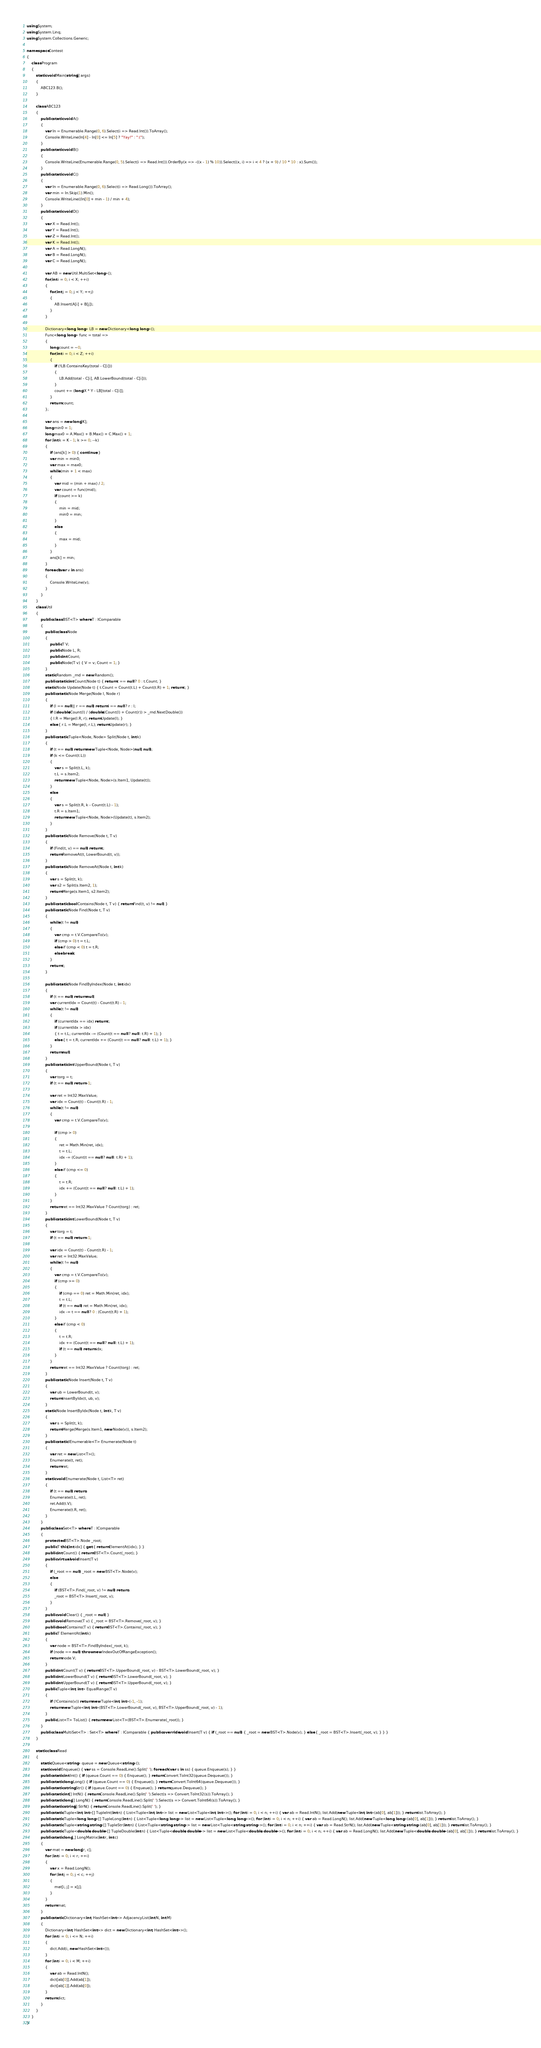<code> <loc_0><loc_0><loc_500><loc_500><_C#_>using System;
using System.Linq;
using System.Collections.Generic;

namespace Contest
{
    class Program
    {
        static void Main(string[] args)
        {
            ABC123.B();
        }

        class ABC123
        {
            public static void A()
            {
                var In = Enumerable.Range(0, 6).Select(i => Read.Int()).ToArray();
                Console.WriteLine(In[4] - In[0] <= In[5] ? "Yay!" : ":(");
            }
            public static void B()
            {
                Console.WriteLine(Enumerable.Range(0, 5).Select(i => Read.Int()).OrderBy(x => -((x - 1) % 10)).Select((x, i) => i < 4 ? (x + 9) / 10 * 10 : x).Sum());
            }
            public static void C()
            {
                var In = Enumerable.Range(0, 6).Select(i => Read.Long()).ToArray();
                var min = In.Skip(1).Min();
                Console.WriteLine((In[0] + min - 1) / min + 4);
            }
            public static void D()
            {
                var X = Read.Int();
                var Y = Read.Int();
                var Z = Read.Int();
                var K = Read.Int();
                var A = Read.LongN();
                var B = Read.LongN();
                var C = Read.LongN();

                var AB = new Util.MultiSet<long>();
                for(int i = 0; i < X; ++i)
                {
                    for(int j = 0; j < Y; ++j)
                    {
                        AB.Insert(A[i] + B[j]);
                    }
                }

                Dictionary<long, long> LB = new Dictionary<long, long>();
                Func<long, long> func = total =>
                {
                    long count = ~0;
                    for(int i = 0; i < Z; ++i)
                    {
                        if (!LB.ContainsKey(total - C[i]))
                        {
                            LB.Add(total - C[i], AB.LowerBound(total - C[i]));
                        }
                        count += (long)X * Y - LB[total - C[i]];
                    }
                    return count;
                };

                var ans = new long[K];
                long min0 = 1;
                long max0 = A.Max() + B.Max() + C.Max() + 1;
                for (int k = K - 1; k >= 0; --k)
                {
                    if (ans[k] > 0) { continue; }
                    var min = min0;
                    var max = max0;
                    while (min + 1 < max)
                    {
                        var mid = (min + max) / 2;
                        var count = func(mid);
                        if (count >= k)
                        {
                            min = mid;
                            min0 = min;
                        }
                        else
                        {
                            max = mid;
                        }
                    }
                    ans[k] = min;
                }
                foreach(var v in ans)
                {
                    Console.WriteLine(v);
                }
            }
        }
        class Util
        {
            public class BST<T> where T : IComparable
            {
                public class Node
                {
                    public T V;
                    public Node L, R;
                    public int Count;
                    public Node(T v) { V = v; Count = 1; }
                }
                static Random _rnd = new Random();
                public static int Count(Node t) { return t == null ? 0 : t.Count; }
                static Node Update(Node t) { t.Count = Count(t.L) + Count(t.R) + 1; return t; }
                public static Node Merge(Node l, Node r)
                {
                    if (l == null || r == null) return l == null ? r : l;
                    if ((double)Count(l) / (double)(Count(l) + Count(r)) > _rnd.NextDouble())
                    { l.R = Merge(l.R, r); return Update(l); }
                    else { r.L = Merge(l, r.L); return Update(r); }
                }
                public static Tuple<Node, Node> Split(Node t, int k)
                {
                    if (t == null) return new Tuple<Node, Node>(null, null);
                    if (k <= Count(t.L))
                    {
                        var s = Split(t.L, k);
                        t.L = s.Item2;
                        return new Tuple<Node, Node>(s.Item1, Update(t));
                    }
                    else
                    {
                        var s = Split(t.R, k - Count(t.L) - 1);
                        t.R = s.Item1;
                        return new Tuple<Node, Node>(Update(t), s.Item2);
                    }
                }
                public static Node Remove(Node t, T v)
                {
                    if (Find(t, v) == null) return t;
                    return RemoveAt(t, LowerBound(t, v));
                }
                public static Node RemoveAt(Node t, int k)
                {
                    var s = Split(t, k);
                    var s2 = Split(s.Item2, 1);
                    return Merge(s.Item1, s2.Item2);
                }
                public static bool Contains(Node t, T v) { return Find(t, v) != null; }
                public static Node Find(Node t, T v)
                {
                    while (t != null)
                    {
                        var cmp = t.V.CompareTo(v);
                        if (cmp > 0) t = t.L;
                        else if (cmp < 0) t = t.R;
                        else break;
                    }
                    return t;
                }

                public static Node FindByIndex(Node t, int idx)
                {
                    if (t == null) return null;
                    var currentIdx = Count(t) - Count(t.R) - 1;
                    while (t != null)
                    {
                        if (currentIdx == idx) return t;
                        if (currentIdx > idx)
                        { t = t.L; currentIdx -= (Count(t == null ? null : t.R) + 1); }
                        else { t = t.R; currentIdx += (Count(t == null ? null : t.L) + 1); }
                    }
                    return null;
                }
                public static int UpperBound(Node t, T v)
                {
                    var torg = t;
                    if (t == null) return -1;

                    var ret = Int32.MaxValue;
                    var idx = Count(t) - Count(t.R) - 1;
                    while (t != null)
                    {
                        var cmp = t.V.CompareTo(v);

                        if (cmp > 0)
                        {
                            ret = Math.Min(ret, idx);
                            t = t.L;
                            idx -= (Count(t == null ? null : t.R) + 1);
                        }
                        else if (cmp <= 0)
                        {
                            t = t.R;
                            idx += (Count(t == null ? null : t.L) + 1);
                        }
                    }
                    return ret == Int32.MaxValue ? Count(torg) : ret;
                }
                public static int LowerBound(Node t, T v)
                {
                    var torg = t;
                    if (t == null) return -1;

                    var idx = Count(t) - Count(t.R) - 1;
                    var ret = Int32.MaxValue;
                    while (t != null)
                    {
                        var cmp = t.V.CompareTo(v);
                        if (cmp >= 0)
                        {
                            if (cmp == 0) ret = Math.Min(ret, idx);
                            t = t.L;
                            if (t == null) ret = Math.Min(ret, idx);
                            idx -= t == null ? 0 : (Count(t.R) + 1);
                        }
                        else if (cmp < 0)
                        {
                            t = t.R;
                            idx += (Count(t == null ? null : t.L) + 1);
                            if (t == null) return idx;
                        }
                    }
                    return ret == Int32.MaxValue ? Count(torg) : ret;
                }
                public static Node Insert(Node t, T v)
                {
                    var ub = LowerBound(t, v);
                    return InsertByIdx(t, ub, v);
                }
                static Node InsertByIdx(Node t, int k, T v)
                {
                    var s = Split(t, k);
                    return Merge(Merge(s.Item1, new Node(v)), s.Item2);
                }
                public static IEnumerable<T> Enumerate(Node t)
                {
                    var ret = new List<T>();
                    Enumerate(t, ret);
                    return ret;
                }
                static void Enumerate(Node t, List<T> ret)
                {
                    if (t == null) return;
                    Enumerate(t.L, ret);
                    ret.Add(t.V);
                    Enumerate(t.R, ret);
                }
            }
            public class Set<T> where T : IComparable
            {
                protected BST<T>.Node _root;
                public T this[int idx] { get { return ElementAt(idx); } }
                public int Count() { return BST<T>.Count(_root); }
                public virtual void Insert(T v)
                {
                    if (_root == null) _root = new BST<T>.Node(v);
                    else
                    {
                        if (BST<T>.Find(_root, v) != null) return;
                        _root = BST<T>.Insert(_root, v);
                    }
                }
                public void Clear() { _root = null; }
                public void Remove(T v) { _root = BST<T>.Remove(_root, v); }
                public bool Contains(T v) { return BST<T>.Contains(_root, v); }
                public T ElementAt(int k)
                {
                    var node = BST<T>.FindByIndex(_root, k);
                    if (node == null) throw new IndexOutOfRangeException();
                    return node.V;
                }
                public int Count(T v) { return BST<T>.UpperBound(_root, v) - BST<T>.LowerBound(_root, v); }
                public int LowerBound(T v) { return BST<T>.LowerBound(_root, v); }
                public int UpperBound(T v) { return BST<T>.UpperBound(_root, v); }
                public Tuple<int, int> EqualRange(T v)
                {
                    if (!Contains(v)) return new Tuple<int, int>(-1, -1);
                    return new Tuple<int, int>(BST<T>.LowerBound(_root, v), BST<T>.UpperBound(_root, v) - 1);
                }
                public List<T> ToList() { return new List<T>(BST<T>.Enumerate(_root)); }
            }
            public class MultiSet<T> : Set<T> where T : IComparable { public override void Insert(T v) { if (_root == null) { _root = new BST<T>.Node(v); } else { _root = BST<T>.Insert(_root, v); } } }
        }

        static class Read
        {
            static Queue<string> queue = new Queue<string>();
            static void Enqueue() { var ss = Console.ReadLine().Split(' '); foreach (var s in ss) { queue.Enqueue(s); } }
            public static int Int() { if (queue.Count == 0) { Enqueue(); } return Convert.ToInt32(queue.Dequeue()); }
            public static long Long() { if (queue.Count == 0) { Enqueue(); } return Convert.ToInt64(queue.Dequeue()); }
            public static string Str() { if (queue.Count == 0) { Enqueue(); } return queue.Dequeue(); }
            public static int[] IntN() { return Console.ReadLine().Split(' ').Select(s => Convert.ToInt32(s)).ToArray(); }
            public static long[] LongN() { return Console.ReadLine().Split(' ').Select(s => Convert.ToInt64(s)).ToArray(); }
            public static string[] StrN() { return Console.ReadLine().Split(' '); }
            public static Tuple<int, int>[] TupleInt(int n) { List<Tuple<int, int>> list = new List<Tuple<int, int>>(); for (int i = 0; i < n; ++i) { var ab = Read.IntN(); list.Add(new Tuple<int, int>(ab[0], ab[1])); } return list.ToArray(); }
            public static Tuple<long, long>[] TupleLong(int n) { List<Tuple<long, long>> list = new List<Tuple<long, long>>(); for (int i = 0; i < n; ++i) { var ab = Read.LongN(); list.Add(new Tuple<long, long>(ab[0], ab[1])); } return list.ToArray(); }
            public static Tuple<string, string>[] TupleStr(int n) { List<Tuple<string, string>> list = new List<Tuple<string, string>>(); for (int i = 0; i < n; ++i) { var ab = Read.StrN(); list.Add(new Tuple<string, string>(ab[0], ab[1])); } return list.ToArray(); }
            public static Tuple<double, double>[] TupleDouble(int n) { List<Tuple<double, double>> list = new List<Tuple<double, double>>(); for (int i = 0; i < n; ++i) { var ab = Read.LongN(); list.Add(new Tuple<double, double>(ab[0], ab[1])); } return list.ToArray(); }
            public static long[,] LongMatrix(int r, int c)
            {
                var mat = new long[r, c];
                for (int i = 0; i < r; ++i)
                {
                    var x = Read.LongN();
                    for (int j = 0; j < c; ++j)
                    {
                        mat[i, j] = x[j];
                    }
                }
                return mat;
            }
            public static Dictionary<int, HashSet<int>> AdjacencyList(int N, int M)
            {
                Dictionary<int, HashSet<int>> dict = new Dictionary<int, HashSet<int>>();
                for (int i = 0; i <= N; ++i)
                {
                    dict.Add(i, new HashSet<int>());
                }
                for (int i = 0; i < M; ++i)
                {
                    var ab = Read.IntN();
                    dict[ab[0]].Add(ab[1]);
                    dict[ab[1]].Add(ab[0]);
                }
                return dict;
            }
        }
    }
}
</code> 